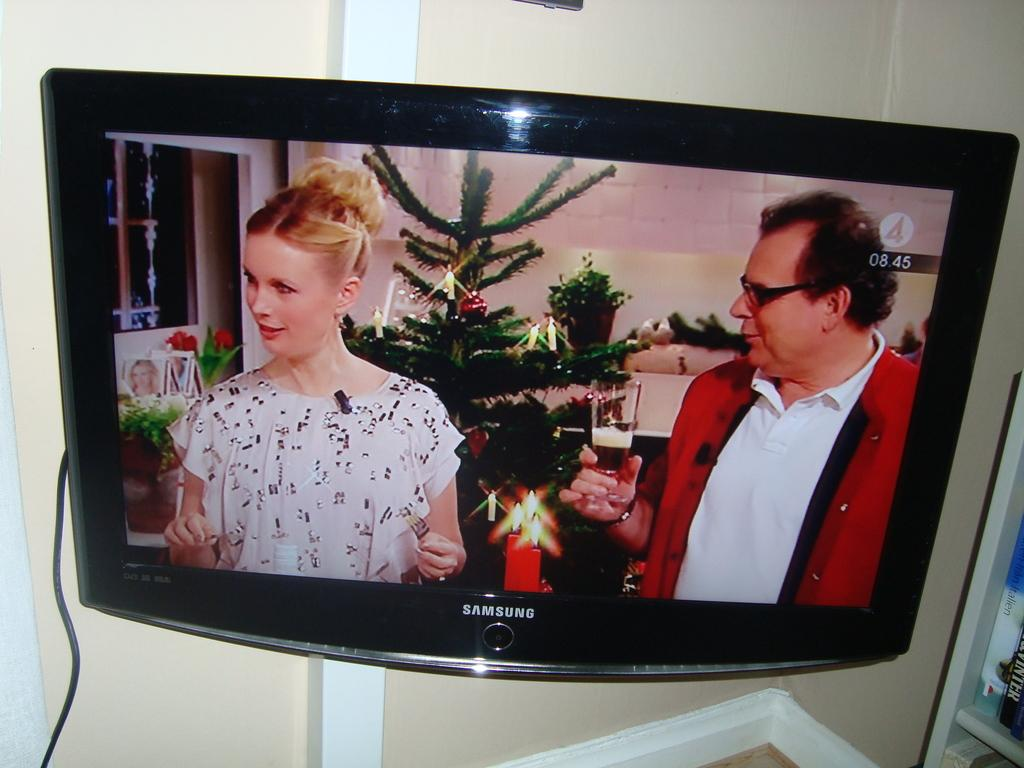<image>
Share a concise interpretation of the image provided. a TV show is playing on a samsung monitor 